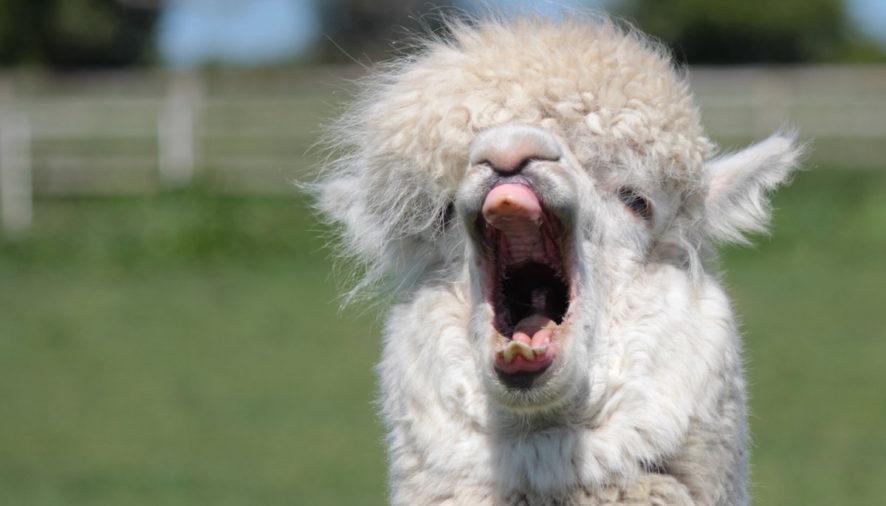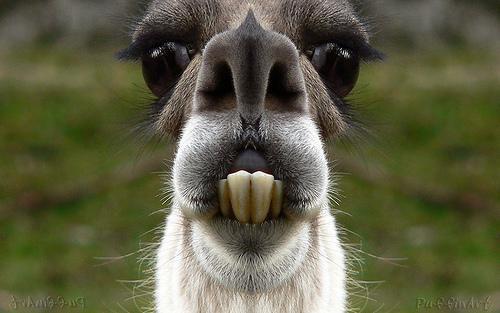The first image is the image on the left, the second image is the image on the right. Assess this claim about the two images: "One image shows a forward-facing llama with projecting lower teeth, and the other image shows a forward-facing llama with woolly white hair on top of its head.". Correct or not? Answer yes or no. Yes. The first image is the image on the left, the second image is the image on the right. Assess this claim about the two images: "there is a llama  with it's mouth open wide showing it's tongue and teeth". Correct or not? Answer yes or no. Yes. 